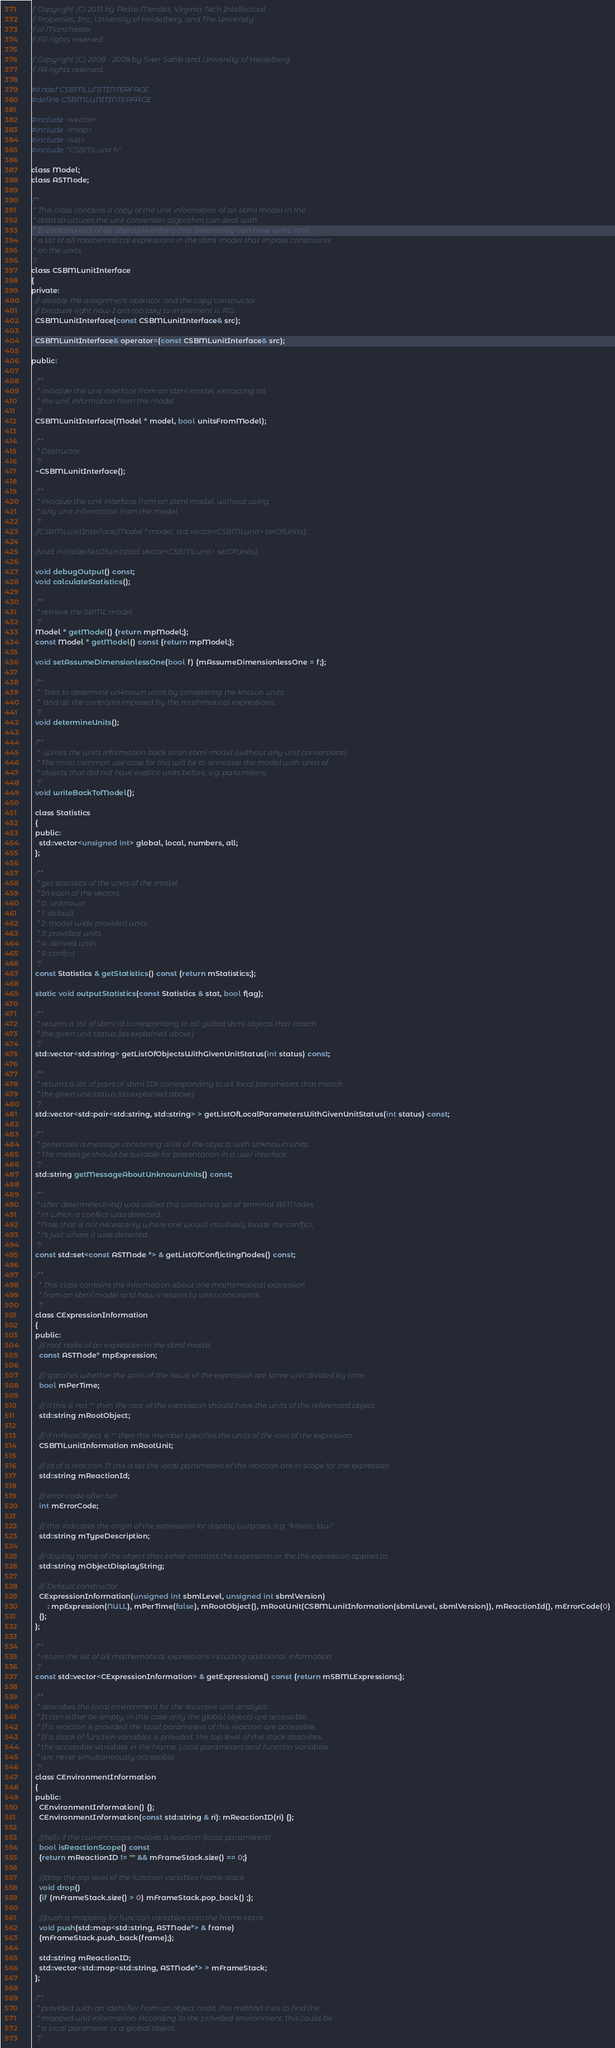<code> <loc_0><loc_0><loc_500><loc_500><_C_>// Copyright (C) 2013 by Pedro Mendes, Virginia Tech Intellectual 
// Properties, Inc., University of Heidelberg, and The University 
// of Manchester. 
// All rights reserved. 

// Copyright (C) 2008 - 2009 by Sven Sahle and University of Heidelberg
// All rights reserved.

#ifndef CSBMLUNITINTERFACE
#define CSBMLUNITINTERFACE

#include <vector>
#include <map>
#include <set>
#include "CSBMLunit.h"

class Model;
class ASTNode;

/**
 * This class contains a copy of the unit information of an sbml model in the
 * data structures the unit conversion algorithm can deal with.
 * It contains lists of all objects/numbers that potentially can have units, and
 * a list of all mathematical expressions in the sbml model that impose constraints
 * on the units.
 */
class CSBMLunitInterface
{
private:
  // disable the assignment operator and the copy constructor
  // because right now I am too lazy to implement it. R.G.
  CSBMLunitInterface(const CSBMLunitInterface& src);

  CSBMLunitInterface& operator=(const CSBMLunitInterface& src);

public:

  /**
   * initialize the unit interface from an sbml model, extracting all
   * the unit information from the model
   */
  CSBMLunitInterface(Model * model, bool unitsFromModel);

  /**
   * Destructor.
   */
  ~CSBMLunitInterface();

  /**
   * initialize the unit interface from an sbml model, without using
   * any unit information from the model
   */
  //CSBMLunitInterface(Model * model, std::vector<CSBMLunit> setOfUnits);

  //void initializeSetOfUnits(std::vector<CSBMLunit> setOfUnits);

  void debugOutput() const;
  void calculateStatistics();

  /**
   * retrieve the SBML model
   */
  Model * getModel() {return mpModel;};
  const Model * getModel() const {return mpModel;};

  void setAssumeDimensionlessOne(bool f) {mAssumeDimensionlessOne = f;};

  /**
   *  Tries to determine unknown units by considering the known units
   *  and all the contrains imposed by the mathmatical expressions.
   */
  void determineUnits();

  /**
   *  Writes the units information back to an sbml model (without any unit conversions).
   * The most common use case for this will be to annotate the model with units of
   * objects that did not have explicit units before, e.g. parameters.
   */
  void writeBackToModel();

  class Statistics
  {
  public:
    std::vector<unsigned int> global, local, numbers, all;
  };

  /**
   * get statistics of the units of the model.
   * In each of the vectors:
   * 0: unknown
   * 1: default
   * 2: model wide provided units
   * 3: provided units
   * 4: derived units
   * 5: conflict
   */
  const Statistics & getStatistics() const {return mStatistics;};

  static void outputStatistics(const Statistics & stat, bool flag);

  /**
   * returns a list of sbml id corresponding to all global sbml objects that match
   * the given unit status (as explained above)
   */
  std::vector<std::string> getListOfObjectsWithGivenUnitStatus(int status) const;

  /**
   * returns a list of pairs of sbml IDs corresponding to all local parameters that match
   * the given unit status (as explained above)
   */
  std::vector<std::pair<std::string, std::string> > getListOfLocalParametersWithGivenUnitStatus(int status) const;

  /**
   * generates a message containing a list of the objects with unknown units.
   * The message should be suitable for presentation in a user interface.
   */
  std::string getMessageAboutUnknownUnits() const;

  /**
   * after determineUnits() was called this contains a set of terminal ASTNodes
   * in which a conflict was detected.
   * Note that is not necessarily where one would intuitively locate the conflict,
   * i's just where it was detected.
   */
  const std::set<const ASTNode *> & getListOfConflictingNodes() const;

  /**
    * This class contains the information about one mathematical expression
    * from an sbml model and how it relates to units constraints.
    */
  class CExpressionInformation
  {
  public:
    /// root node of an expression in the sbml model
    const ASTNode* mpExpression;

    /// specifies whether the units of the result of the expression are some unit divided by time
    bool mPerTime;

    /// if this is not "" then the root of the expression should have the units of the referenced object
    std::string mRootObject;

    /// if mRootObject is "" then this member specifies the units of the root of the expression
    CSBMLunitInformation mRootUnit;

    /// id of a reaction. If this is set the local parameters of the reaction are in scope for the expression
    std::string mReactionId;

    /// error code after run
    int mErrorCode;

    /// this indicates the origin of the expression for display purposes, e.g. "kinetic law"
    std::string mTypeDescription;

    /// display name of the object that either contains the expression or the the expression applies to.
    std::string mObjectDisplayString;

    /// Default constructor
    CExpressionInformation(unsigned int sbmlLevel, unsigned int sbmlVersion)
        : mpExpression(NULL), mPerTime(false), mRootObject(), mRootUnit(CSBMLunitInformation(sbmlLevel, sbmlVersion)), mReactionId(), mErrorCode(0)
    {};
  };

  /**
   * return the list of all mathematical expressions including additional information
   */
  const std::vector<CExpressionInformation> & getExpressions() const {return mSBMLExpressions;};

  /**
   * describes the local environment for the recursive unit analysis.
   * It can either be empty, in this case only the global objects are accessible.
   * If a reaction is provided the local parameters of this reaction are accessible.
   * If a stack of function variables is provided, the top level of this stack describes
   * the accessible variables in the frame. Local parameters and function variables
   * are never simultaneously accessible.
   */
  class CEnvironmentInformation
  {
  public:
    CEnvironmentInformation() {};
    CEnvironmentInformation(const std::string & ri): mReactionID(ri) {};

    ///tells if the current scope involves a reaction (local parameters)
    bool isReactionScope() const
    {return mReactionID != "" && mFrameStack.size() == 0;}

    ///drop the top level of the function variables frame stack
    void drop()
    {if (mFrameStack.size() > 0) mFrameStack.pop_back() ;};

    ///push a mapping for function variables onto the frame stack
    void push(std::map<std::string, ASTNode*> & frame)
    {mFrameStack.push_back(frame);};

    std::string mReactionID;
    std::vector<std::map<std::string, ASTNode*> > mFrameStack;
  };

  /**
   * provided with an identifier from an object node, this method tries to find the
   * mapped unit information. According to the provided environment, this could be
   * a local parameter or a global object.
   */</code> 